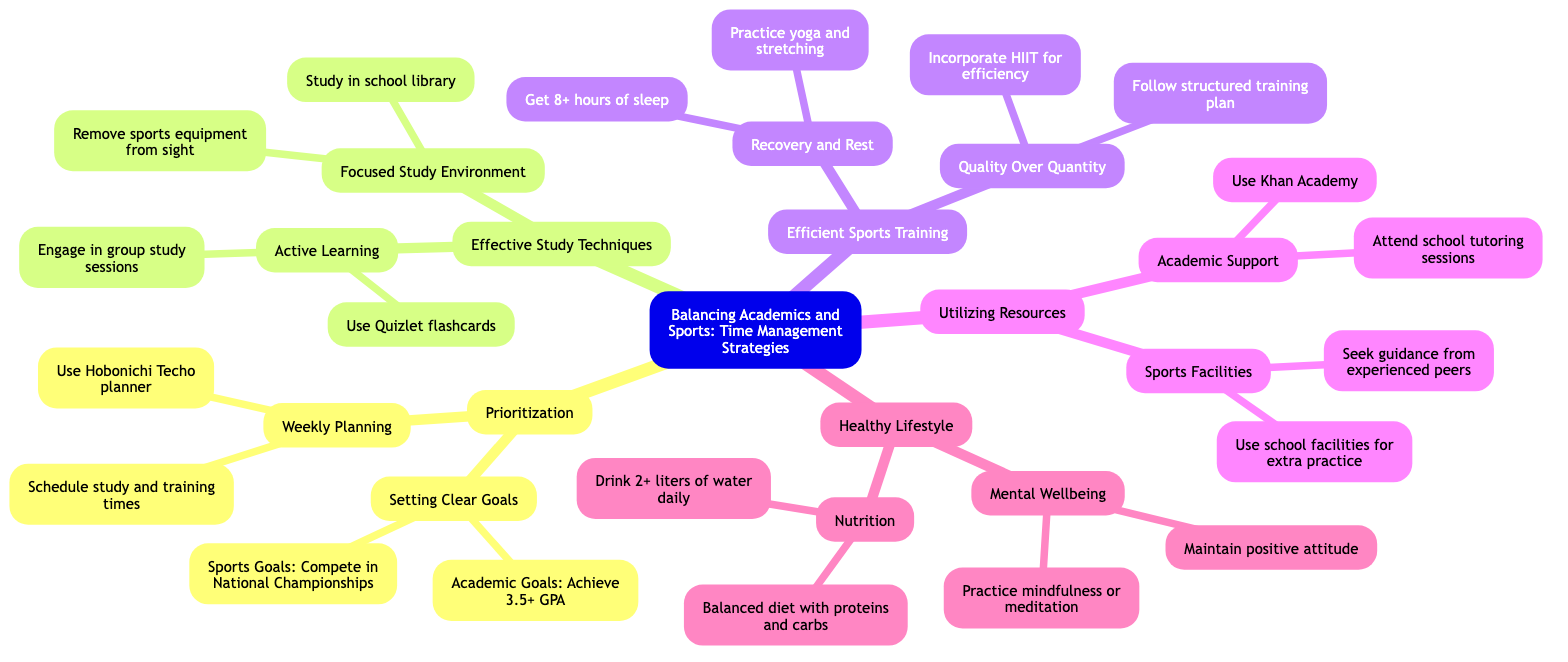What is the central theme of the mind map? The central theme at the root of the mind map is explicitly stated and identifies the main focus of the diagram, which is balancing academics and sports through time management strategies.
Answer: Balancing Academics and Sports: Time Management Strategies How many main branches are present in the mind map? By counting each main division from the center, there are a total of five distinct branches that represent different strategies related to the central theme.
Answer: 5 What is one academic goal mentioned in the diagram? The diagram lists specific academic goals under the "Setting Clear Goals" node, one of which is achieving a minimum GPA of 3.5.
Answer: Achieving a minimum GPA of 3.5 Which planning tool is recommended for scheduling in the mind map? The recommended tool for scheduling study sessions and training in "Weekly Planning" is explicitly mentioned as the Hobonichi Techo planner.
Answer: Hobonichi Techo planner What type of training is suggested for efficiency in sports? The mind map suggests incorporating high-intensity interval training, commonly referred to as HIIT, under the "Quality Over Quantity" node in efficient sports training.
Answer: HIIT How does the mind map suggest minimizing distractions during study? The recommendation under "Focused Study Environment" highlights the necessity of studying in a quiet place and making sure that all sports equipment is out of sight to reduce interruptions.
Answer: Remove sports equipment from sight Which two aspects does maintaining a healthy lifestyle focus on according to the diagram? The "Healthy Lifestyle" branch breaks down into two main focuses: Nutrition and Mental Wellbeing, signifying a balanced approach.
Answer: Nutrition and Mental Wellbeing What academic support resource does the mind map mention? One of the resources suggested under "Academic Support" is attending tutoring sessions provided by Saitama Sakae High School, ensuring additional academic help is available.
Answer: Attend school tutoring sessions What should students maintain for optimal sleep, as per the mind map? The health strategy indicates ensuring adequate sleep of at least 8 hours a night under the "Recovery and Rest" node, emphasizing its importance for athlete recovery.
Answer: 8 hours 